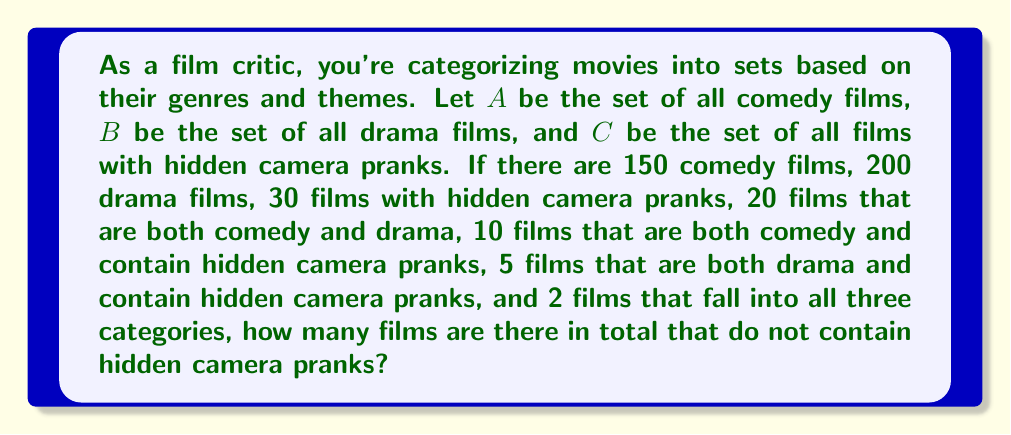Can you answer this question? Let's approach this step-by-step using set theory:

1) First, we need to find the total number of films in all categories. We can use the inclusion-exclusion principle:

   $$|A \cup B \cup C| = |A| + |B| + |C| - |A \cap B| - |A \cap C| - |B \cap C| + |A \cap B \cap C|$$

2) Substituting the given values:

   $$|A \cup B \cup C| = 150 + 200 + 30 - 20 - 10 - 5 + 2 = 347$$

3) Now, we need to find the number of films that contain hidden camera pranks (set C). We already know this is 30.

4) To find the number of films without hidden camera pranks, we subtract the number of films with hidden camera pranks from the total:

   $$\text{Films without hidden camera pranks} = |A \cup B \cup C| - |C| = 347 - 30 = 317$$

Therefore, there are 317 films that do not contain hidden camera pranks.
Answer: 317 films 